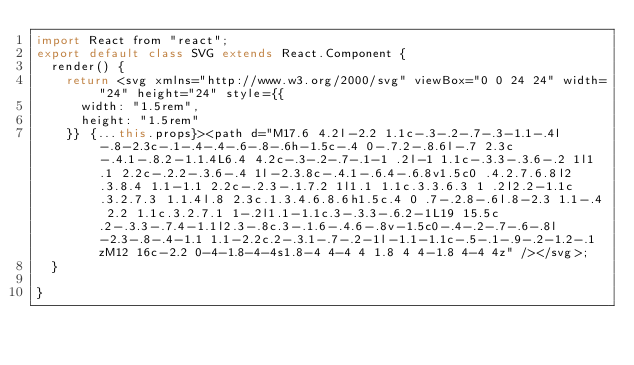<code> <loc_0><loc_0><loc_500><loc_500><_JavaScript_>import React from "react";
export default class SVG extends React.Component {
  render() {
    return <svg xmlns="http://www.w3.org/2000/svg" viewBox="0 0 24 24" width="24" height="24" style={{
      width: "1.5rem",
      height: "1.5rem"
    }} {...this.props}><path d="M17.6 4.2l-2.2 1.1c-.3-.2-.7-.3-1.1-.4l-.8-2.3c-.1-.4-.4-.6-.8-.6h-1.5c-.4 0-.7.2-.8.6l-.7 2.3c-.4.1-.8.2-1.1.4L6.4 4.2c-.3-.2-.7-.1-1 .2l-1 1.1c-.3.3-.3.6-.2 1l1.1 2.2c-.2.2-.3.6-.4 1l-2.3.8c-.4.1-.6.4-.6.8v1.5c0 .4.2.7.6.8l2.3.8.4 1.1-1.1 2.2c-.2.3-.1.7.2 1l1.1 1.1c.3.3.6.3 1 .2l2.2-1.1c.3.2.7.3 1.1.4l.8 2.3c.1.3.4.6.8.6h1.5c.4 0 .7-.2.8-.6l.8-2.3 1.1-.4 2.2 1.1c.3.2.7.1 1-.2l1.1-1.1c.3-.3.3-.6.2-1L19 15.5c.2-.3.3-.7.4-1.1l2.3-.8c.3-.1.6-.4.6-.8v-1.5c0-.4-.2-.7-.6-.8l-2.3-.8-.4-1.1 1.1-2.2c.2-.3.1-.7-.2-1l-1.1-1.1c-.5-.1-.9-.2-1.2-.1zM12 16c-2.2 0-4-1.8-4-4s1.8-4 4-4 4 1.8 4 4-1.8 4-4 4z" /></svg>;
  }

}</code> 